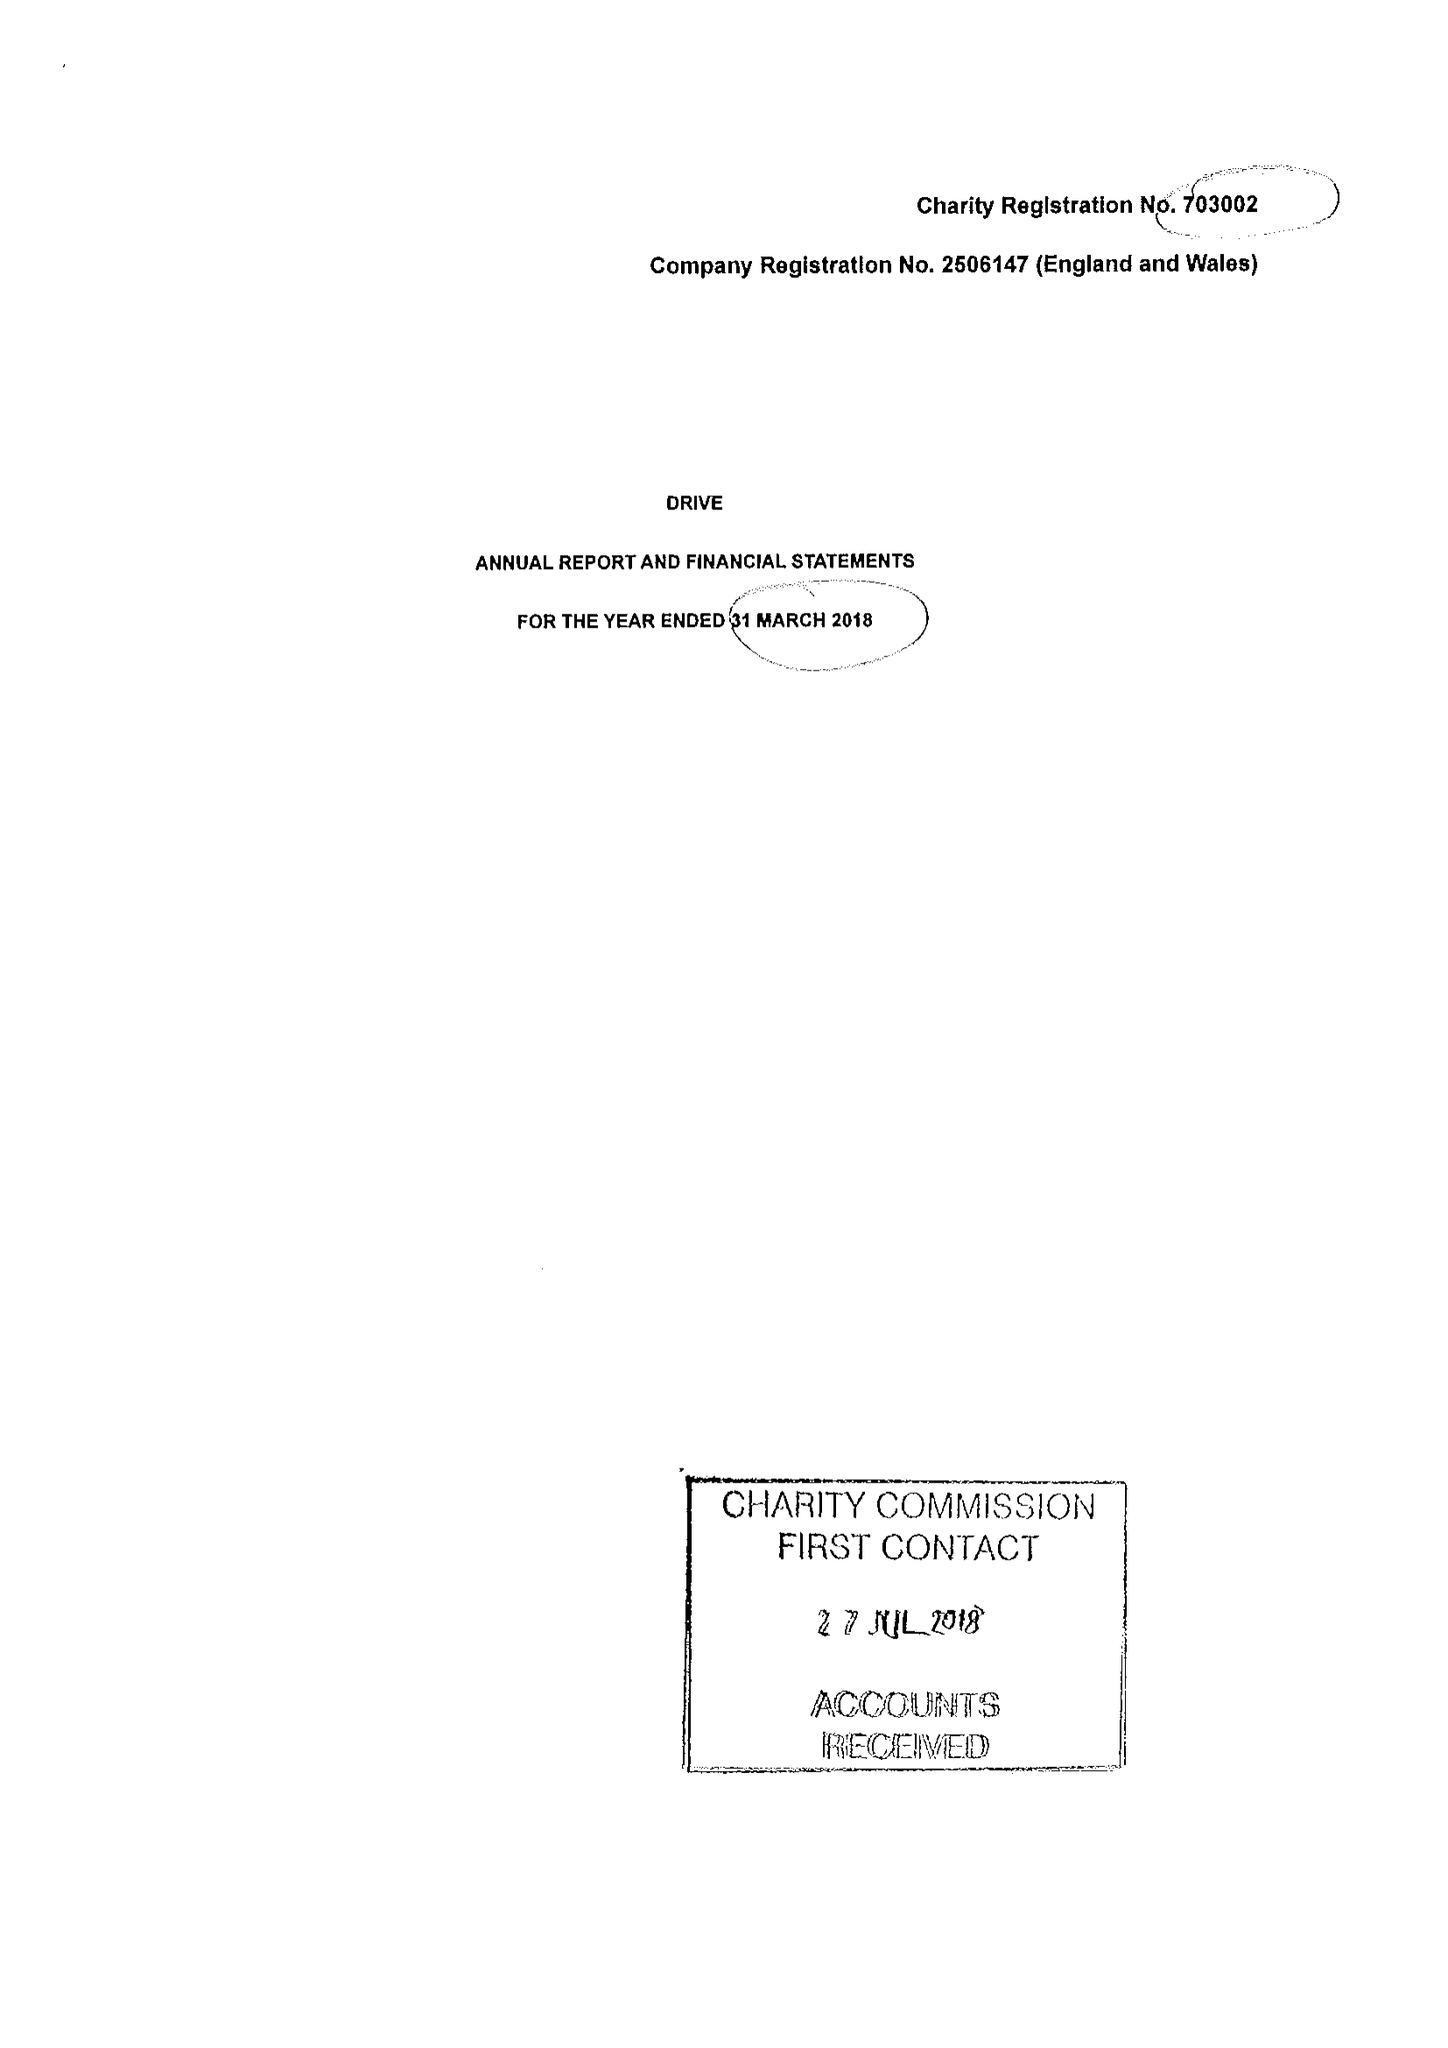What is the value for the report_date?
Answer the question using a single word or phrase. 2018-03-31 